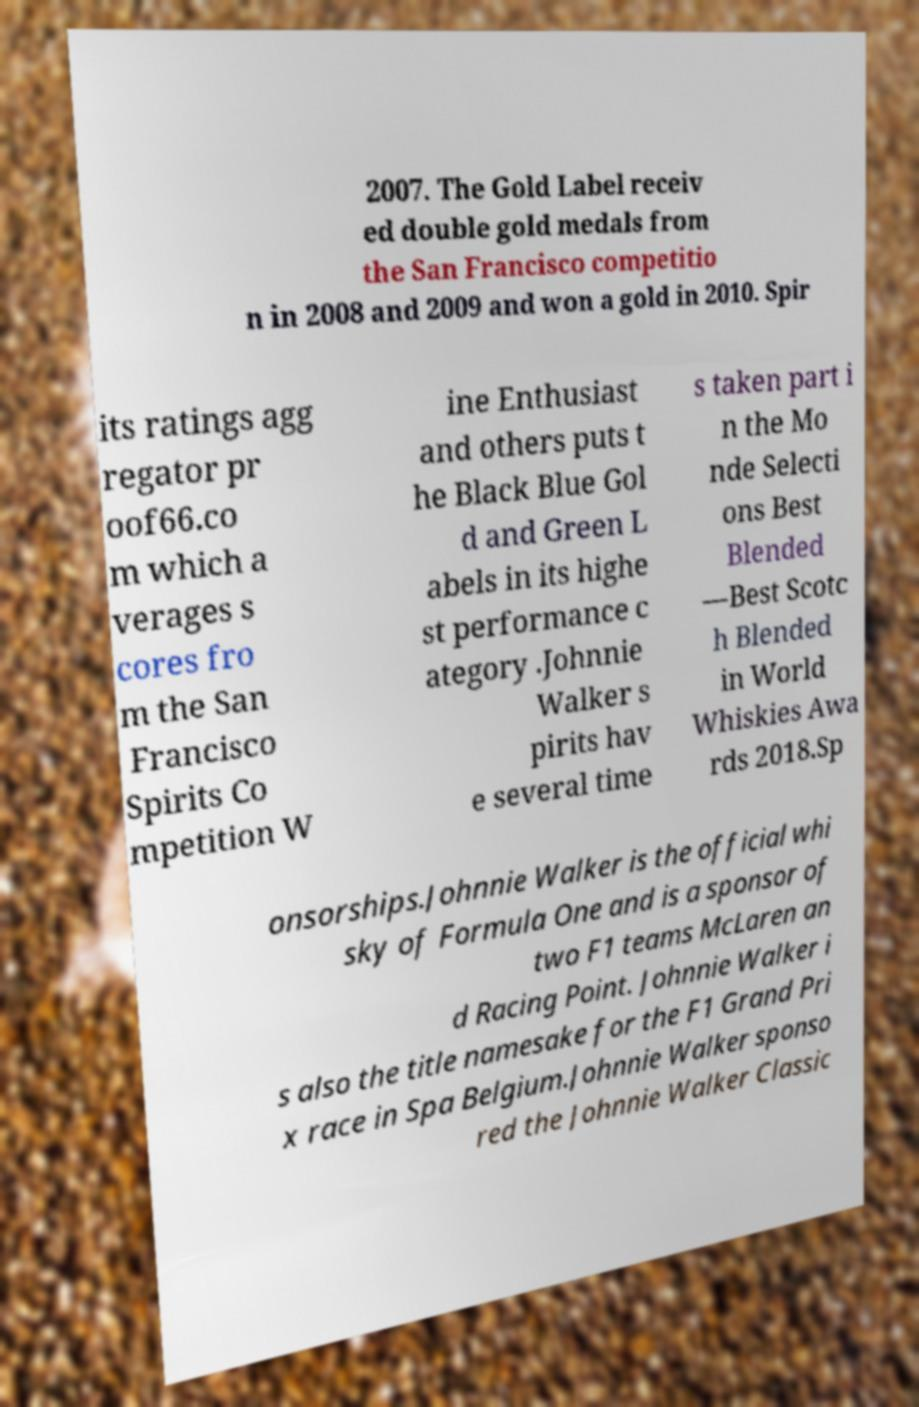What messages or text are displayed in this image? I need them in a readable, typed format. 2007. The Gold Label receiv ed double gold medals from the San Francisco competitio n in 2008 and 2009 and won a gold in 2010. Spir its ratings agg regator pr oof66.co m which a verages s cores fro m the San Francisco Spirits Co mpetition W ine Enthusiast and others puts t he Black Blue Gol d and Green L abels in its highe st performance c ategory .Johnnie Walker s pirits hav e several time s taken part i n the Mo nde Selecti ons Best Blended —Best Scotc h Blended in World Whiskies Awa rds 2018.Sp onsorships.Johnnie Walker is the official whi sky of Formula One and is a sponsor of two F1 teams McLaren an d Racing Point. Johnnie Walker i s also the title namesake for the F1 Grand Pri x race in Spa Belgium.Johnnie Walker sponso red the Johnnie Walker Classic 